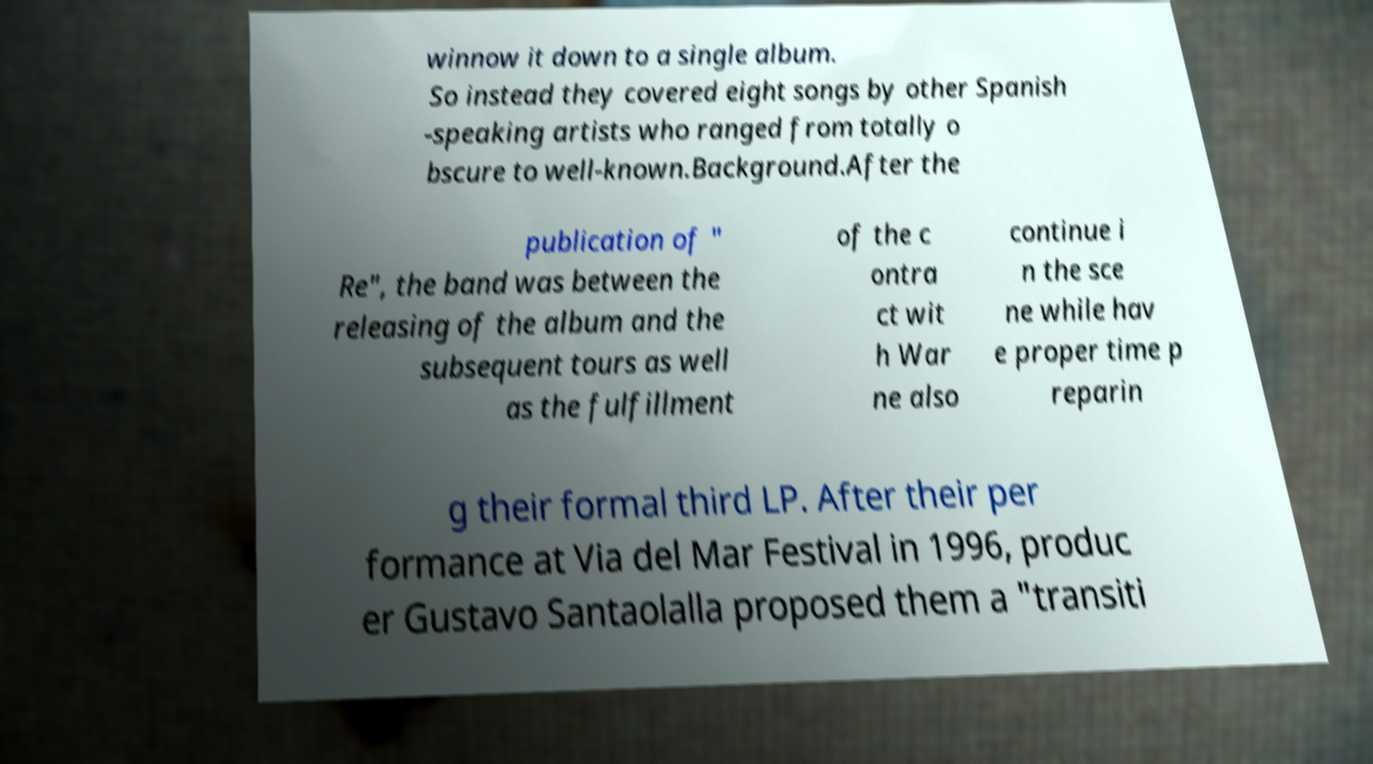Could you assist in decoding the text presented in this image and type it out clearly? winnow it down to a single album. So instead they covered eight songs by other Spanish -speaking artists who ranged from totally o bscure to well-known.Background.After the publication of " Re", the band was between the releasing of the album and the subsequent tours as well as the fulfillment of the c ontra ct wit h War ne also continue i n the sce ne while hav e proper time p reparin g their formal third LP. After their per formance at Via del Mar Festival in 1996, produc er Gustavo Santaolalla proposed them a "transiti 